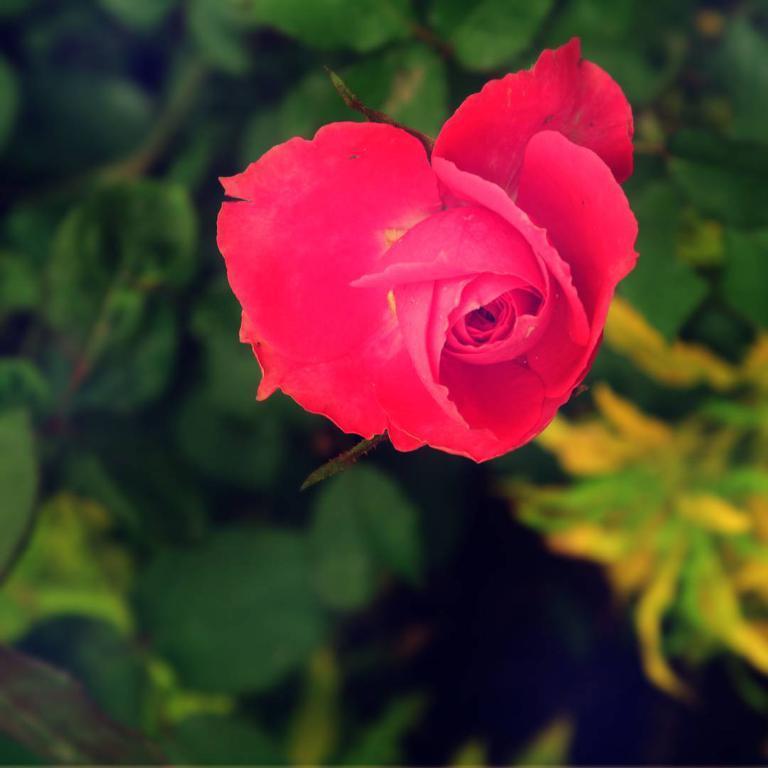Please provide a concise description of this image. In this image we can see red color rose flower. In the background there are leaves. 